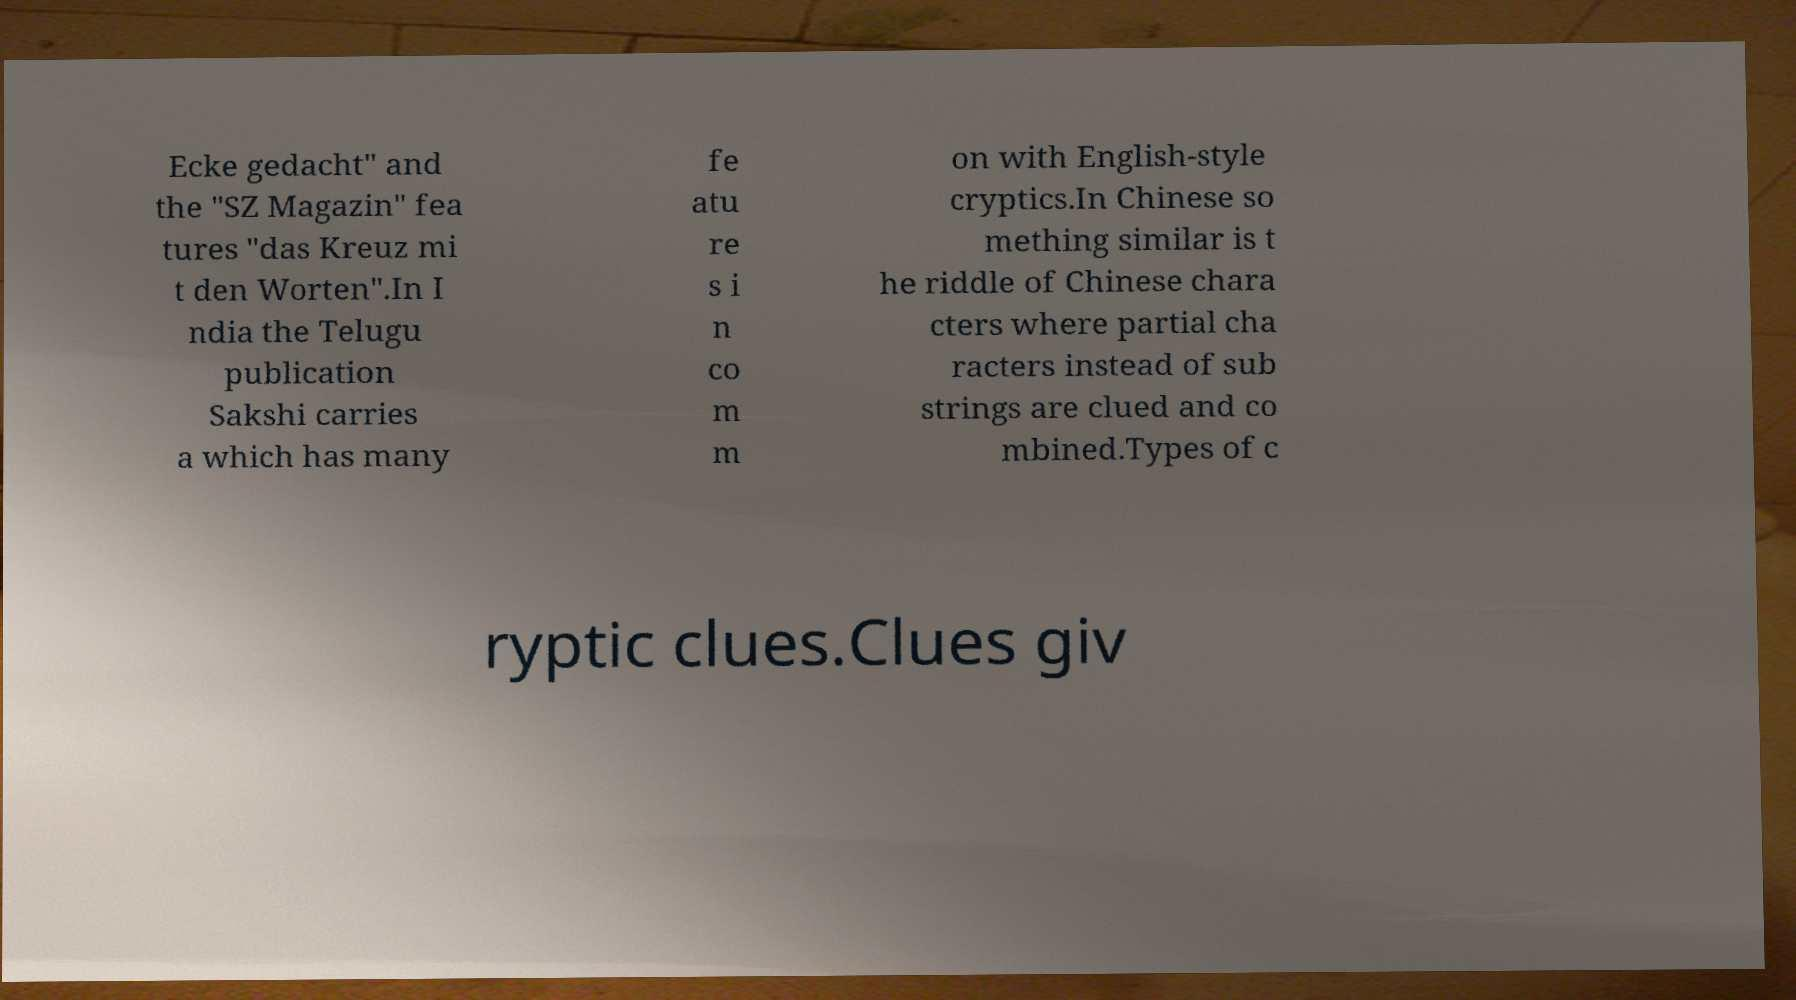What messages or text are displayed in this image? I need them in a readable, typed format. Ecke gedacht" and the "SZ Magazin" fea tures "das Kreuz mi t den Worten".In I ndia the Telugu publication Sakshi carries a which has many fe atu re s i n co m m on with English-style cryptics.In Chinese so mething similar is t he riddle of Chinese chara cters where partial cha racters instead of sub strings are clued and co mbined.Types of c ryptic clues.Clues giv 